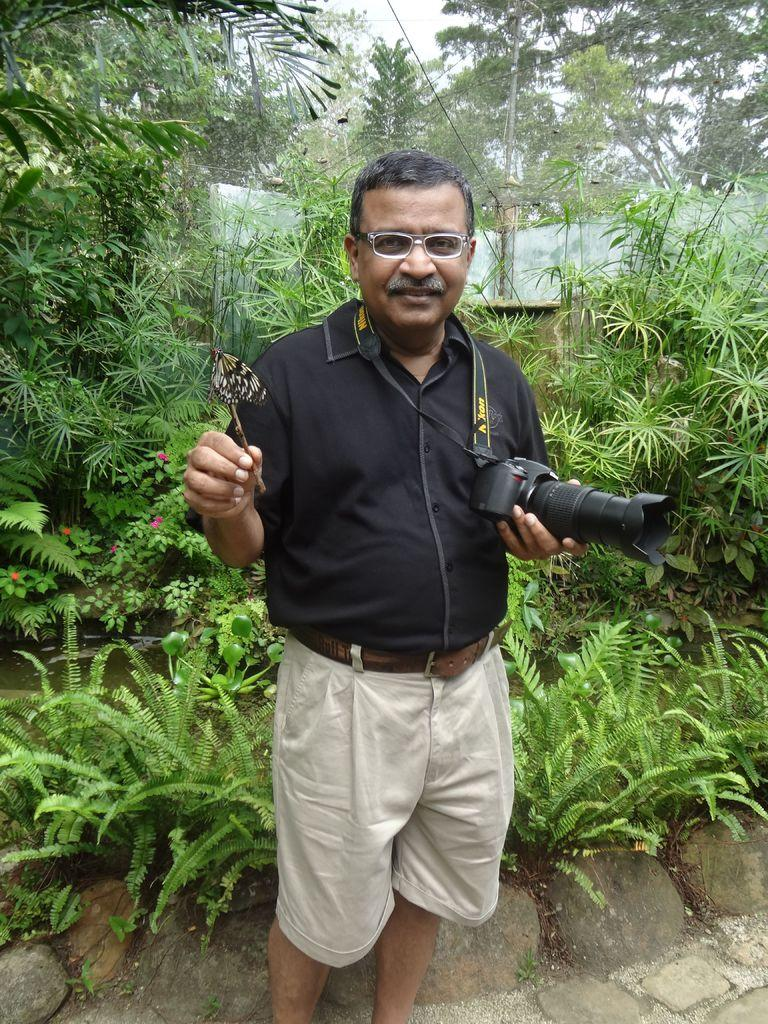What is the person in the image holding? The person in the image is holding a camera. What is the butterfly in the image associated with? The butterfly in the image has a stick. What type of natural elements can be seen in the image? Stones, plants, trees, and the sky are visible in the image. What man-made structures are present in the image? There is a fence and a pole in the image. What theory is the person in the image trying to prove with the camera? There is no indication in the image that the person is trying to prove a theory with the camera. How many months does the butterfly spend in the image? The image does not depict the passage of time, so it is impossible to determine how many months the butterfly spends in the image. 